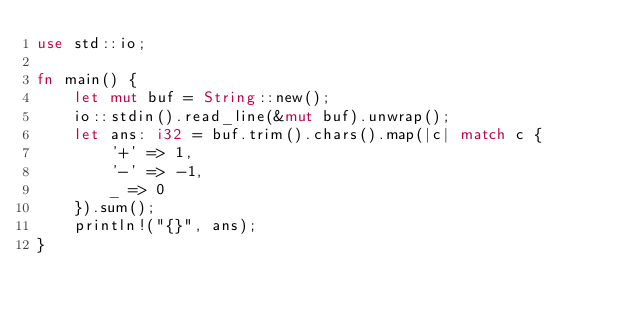<code> <loc_0><loc_0><loc_500><loc_500><_Rust_>use std::io;

fn main() {
    let mut buf = String::new();
    io::stdin().read_line(&mut buf).unwrap();
    let ans: i32 = buf.trim().chars().map(|c| match c {
        '+' => 1,
        '-' => -1,
        _ => 0
    }).sum();
    println!("{}", ans);
}
</code> 